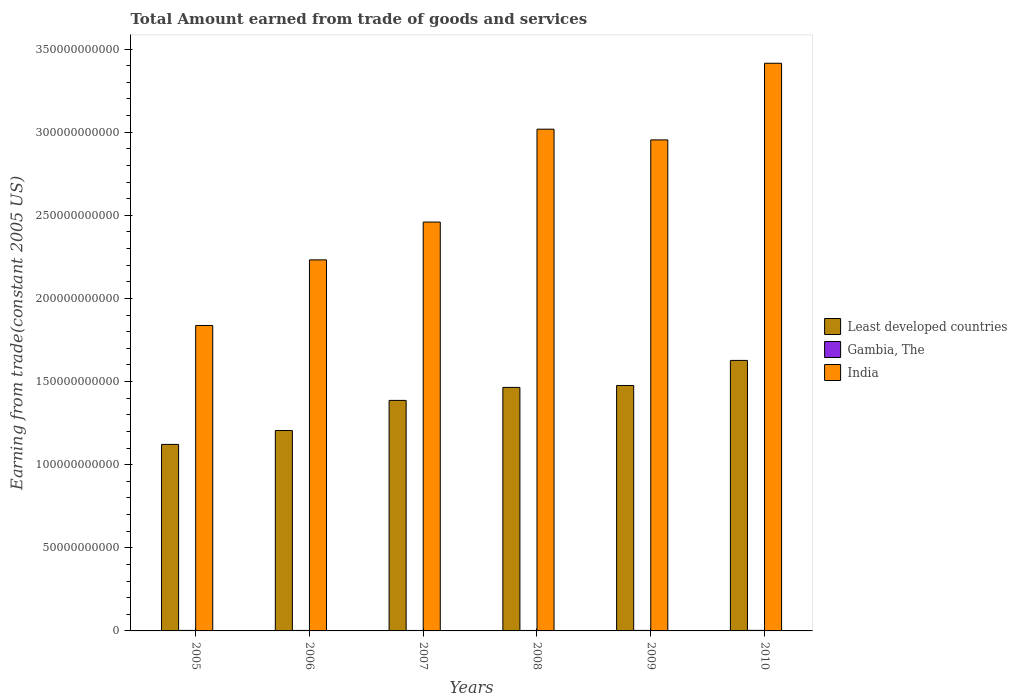How many different coloured bars are there?
Give a very brief answer. 3. How many groups of bars are there?
Provide a short and direct response. 6. Are the number of bars on each tick of the X-axis equal?
Provide a short and direct response. Yes. How many bars are there on the 4th tick from the left?
Your answer should be compact. 3. How many bars are there on the 5th tick from the right?
Your response must be concise. 3. In how many cases, is the number of bars for a given year not equal to the number of legend labels?
Offer a very short reply. 0. What is the total amount earned by trading goods and services in Gambia, The in 2006?
Ensure brevity in your answer.  2.98e+08. Across all years, what is the maximum total amount earned by trading goods and services in Least developed countries?
Your answer should be very brief. 1.63e+11. Across all years, what is the minimum total amount earned by trading goods and services in Gambia, The?
Provide a succinct answer. 2.75e+08. In which year was the total amount earned by trading goods and services in Gambia, The minimum?
Make the answer very short. 2007. What is the total total amount earned by trading goods and services in India in the graph?
Your answer should be very brief. 1.59e+12. What is the difference between the total amount earned by trading goods and services in Least developed countries in 2009 and that in 2010?
Offer a very short reply. -1.51e+1. What is the difference between the total amount earned by trading goods and services in Gambia, The in 2005 and the total amount earned by trading goods and services in Least developed countries in 2006?
Your response must be concise. -1.20e+11. What is the average total amount earned by trading goods and services in Gambia, The per year?
Keep it short and to the point. 3.00e+08. In the year 2005, what is the difference between the total amount earned by trading goods and services in Gambia, The and total amount earned by trading goods and services in India?
Make the answer very short. -1.83e+11. In how many years, is the total amount earned by trading goods and services in India greater than 130000000000 US$?
Provide a succinct answer. 6. What is the ratio of the total amount earned by trading goods and services in Least developed countries in 2006 to that in 2007?
Make the answer very short. 0.87. What is the difference between the highest and the second highest total amount earned by trading goods and services in Gambia, The?
Your answer should be very brief. 2.56e+07. What is the difference between the highest and the lowest total amount earned by trading goods and services in India?
Offer a very short reply. 1.58e+11. In how many years, is the total amount earned by trading goods and services in Least developed countries greater than the average total amount earned by trading goods and services in Least developed countries taken over all years?
Give a very brief answer. 4. Is the sum of the total amount earned by trading goods and services in Gambia, The in 2005 and 2006 greater than the maximum total amount earned by trading goods and services in India across all years?
Offer a terse response. No. What does the 3rd bar from the right in 2006 represents?
Your answer should be compact. Least developed countries. Is it the case that in every year, the sum of the total amount earned by trading goods and services in Least developed countries and total amount earned by trading goods and services in India is greater than the total amount earned by trading goods and services in Gambia, The?
Your answer should be compact. Yes. How many bars are there?
Your answer should be compact. 18. How many years are there in the graph?
Offer a very short reply. 6. What is the difference between two consecutive major ticks on the Y-axis?
Your answer should be very brief. 5.00e+1. Does the graph contain grids?
Ensure brevity in your answer.  No. How many legend labels are there?
Make the answer very short. 3. How are the legend labels stacked?
Make the answer very short. Vertical. What is the title of the graph?
Your answer should be compact. Total Amount earned from trade of goods and services. Does "Cambodia" appear as one of the legend labels in the graph?
Make the answer very short. No. What is the label or title of the X-axis?
Give a very brief answer. Years. What is the label or title of the Y-axis?
Your response must be concise. Earning from trade(constant 2005 US). What is the Earning from trade(constant 2005 US) in Least developed countries in 2005?
Ensure brevity in your answer.  1.12e+11. What is the Earning from trade(constant 2005 US) in Gambia, The in 2005?
Ensure brevity in your answer.  3.09e+08. What is the Earning from trade(constant 2005 US) of India in 2005?
Make the answer very short. 1.84e+11. What is the Earning from trade(constant 2005 US) in Least developed countries in 2006?
Offer a terse response. 1.21e+11. What is the Earning from trade(constant 2005 US) in Gambia, The in 2006?
Provide a short and direct response. 2.98e+08. What is the Earning from trade(constant 2005 US) in India in 2006?
Make the answer very short. 2.23e+11. What is the Earning from trade(constant 2005 US) in Least developed countries in 2007?
Keep it short and to the point. 1.39e+11. What is the Earning from trade(constant 2005 US) of Gambia, The in 2007?
Offer a very short reply. 2.75e+08. What is the Earning from trade(constant 2005 US) in India in 2007?
Your response must be concise. 2.46e+11. What is the Earning from trade(constant 2005 US) in Least developed countries in 2008?
Your answer should be very brief. 1.46e+11. What is the Earning from trade(constant 2005 US) of Gambia, The in 2008?
Your answer should be compact. 2.76e+08. What is the Earning from trade(constant 2005 US) of India in 2008?
Provide a short and direct response. 3.02e+11. What is the Earning from trade(constant 2005 US) of Least developed countries in 2009?
Provide a short and direct response. 1.48e+11. What is the Earning from trade(constant 2005 US) in Gambia, The in 2009?
Ensure brevity in your answer.  3.07e+08. What is the Earning from trade(constant 2005 US) in India in 2009?
Your answer should be very brief. 2.95e+11. What is the Earning from trade(constant 2005 US) of Least developed countries in 2010?
Ensure brevity in your answer.  1.63e+11. What is the Earning from trade(constant 2005 US) in Gambia, The in 2010?
Your response must be concise. 3.35e+08. What is the Earning from trade(constant 2005 US) of India in 2010?
Your answer should be compact. 3.41e+11. Across all years, what is the maximum Earning from trade(constant 2005 US) of Least developed countries?
Your answer should be very brief. 1.63e+11. Across all years, what is the maximum Earning from trade(constant 2005 US) in Gambia, The?
Your answer should be very brief. 3.35e+08. Across all years, what is the maximum Earning from trade(constant 2005 US) in India?
Ensure brevity in your answer.  3.41e+11. Across all years, what is the minimum Earning from trade(constant 2005 US) of Least developed countries?
Provide a short and direct response. 1.12e+11. Across all years, what is the minimum Earning from trade(constant 2005 US) in Gambia, The?
Make the answer very short. 2.75e+08. Across all years, what is the minimum Earning from trade(constant 2005 US) in India?
Your answer should be compact. 1.84e+11. What is the total Earning from trade(constant 2005 US) in Least developed countries in the graph?
Provide a short and direct response. 8.28e+11. What is the total Earning from trade(constant 2005 US) of Gambia, The in the graph?
Ensure brevity in your answer.  1.80e+09. What is the total Earning from trade(constant 2005 US) in India in the graph?
Offer a terse response. 1.59e+12. What is the difference between the Earning from trade(constant 2005 US) of Least developed countries in 2005 and that in 2006?
Offer a terse response. -8.35e+09. What is the difference between the Earning from trade(constant 2005 US) of Gambia, The in 2005 and that in 2006?
Your answer should be compact. 1.14e+07. What is the difference between the Earning from trade(constant 2005 US) of India in 2005 and that in 2006?
Give a very brief answer. -3.95e+1. What is the difference between the Earning from trade(constant 2005 US) of Least developed countries in 2005 and that in 2007?
Offer a very short reply. -2.65e+1. What is the difference between the Earning from trade(constant 2005 US) of Gambia, The in 2005 and that in 2007?
Provide a succinct answer. 3.42e+07. What is the difference between the Earning from trade(constant 2005 US) of India in 2005 and that in 2007?
Provide a succinct answer. -6.22e+1. What is the difference between the Earning from trade(constant 2005 US) in Least developed countries in 2005 and that in 2008?
Ensure brevity in your answer.  -3.43e+1. What is the difference between the Earning from trade(constant 2005 US) in Gambia, The in 2005 and that in 2008?
Offer a very short reply. 3.35e+07. What is the difference between the Earning from trade(constant 2005 US) in India in 2005 and that in 2008?
Keep it short and to the point. -1.18e+11. What is the difference between the Earning from trade(constant 2005 US) in Least developed countries in 2005 and that in 2009?
Keep it short and to the point. -3.54e+1. What is the difference between the Earning from trade(constant 2005 US) in Gambia, The in 2005 and that in 2009?
Keep it short and to the point. 2.33e+06. What is the difference between the Earning from trade(constant 2005 US) in India in 2005 and that in 2009?
Provide a succinct answer. -1.12e+11. What is the difference between the Earning from trade(constant 2005 US) in Least developed countries in 2005 and that in 2010?
Provide a succinct answer. -5.05e+1. What is the difference between the Earning from trade(constant 2005 US) in Gambia, The in 2005 and that in 2010?
Ensure brevity in your answer.  -2.56e+07. What is the difference between the Earning from trade(constant 2005 US) in India in 2005 and that in 2010?
Your answer should be very brief. -1.58e+11. What is the difference between the Earning from trade(constant 2005 US) in Least developed countries in 2006 and that in 2007?
Your response must be concise. -1.81e+1. What is the difference between the Earning from trade(constant 2005 US) in Gambia, The in 2006 and that in 2007?
Offer a terse response. 2.28e+07. What is the difference between the Earning from trade(constant 2005 US) of India in 2006 and that in 2007?
Your answer should be compact. -2.28e+1. What is the difference between the Earning from trade(constant 2005 US) of Least developed countries in 2006 and that in 2008?
Your response must be concise. -2.59e+1. What is the difference between the Earning from trade(constant 2005 US) in Gambia, The in 2006 and that in 2008?
Provide a succinct answer. 2.22e+07. What is the difference between the Earning from trade(constant 2005 US) in India in 2006 and that in 2008?
Provide a succinct answer. -7.86e+1. What is the difference between the Earning from trade(constant 2005 US) in Least developed countries in 2006 and that in 2009?
Offer a very short reply. -2.71e+1. What is the difference between the Earning from trade(constant 2005 US) of Gambia, The in 2006 and that in 2009?
Make the answer very short. -9.03e+06. What is the difference between the Earning from trade(constant 2005 US) of India in 2006 and that in 2009?
Offer a very short reply. -7.22e+1. What is the difference between the Earning from trade(constant 2005 US) of Least developed countries in 2006 and that in 2010?
Offer a very short reply. -4.22e+1. What is the difference between the Earning from trade(constant 2005 US) in Gambia, The in 2006 and that in 2010?
Provide a succinct answer. -3.70e+07. What is the difference between the Earning from trade(constant 2005 US) in India in 2006 and that in 2010?
Provide a short and direct response. -1.18e+11. What is the difference between the Earning from trade(constant 2005 US) in Least developed countries in 2007 and that in 2008?
Offer a terse response. -7.82e+09. What is the difference between the Earning from trade(constant 2005 US) in Gambia, The in 2007 and that in 2008?
Ensure brevity in your answer.  -6.49e+05. What is the difference between the Earning from trade(constant 2005 US) in India in 2007 and that in 2008?
Provide a succinct answer. -5.59e+1. What is the difference between the Earning from trade(constant 2005 US) in Least developed countries in 2007 and that in 2009?
Ensure brevity in your answer.  -8.96e+09. What is the difference between the Earning from trade(constant 2005 US) of Gambia, The in 2007 and that in 2009?
Ensure brevity in your answer.  -3.19e+07. What is the difference between the Earning from trade(constant 2005 US) of India in 2007 and that in 2009?
Provide a short and direct response. -4.94e+1. What is the difference between the Earning from trade(constant 2005 US) of Least developed countries in 2007 and that in 2010?
Give a very brief answer. -2.40e+1. What is the difference between the Earning from trade(constant 2005 US) in Gambia, The in 2007 and that in 2010?
Your answer should be compact. -5.98e+07. What is the difference between the Earning from trade(constant 2005 US) in India in 2007 and that in 2010?
Your response must be concise. -9.55e+1. What is the difference between the Earning from trade(constant 2005 US) in Least developed countries in 2008 and that in 2009?
Ensure brevity in your answer.  -1.15e+09. What is the difference between the Earning from trade(constant 2005 US) in Gambia, The in 2008 and that in 2009?
Offer a terse response. -3.12e+07. What is the difference between the Earning from trade(constant 2005 US) in India in 2008 and that in 2009?
Ensure brevity in your answer.  6.45e+09. What is the difference between the Earning from trade(constant 2005 US) in Least developed countries in 2008 and that in 2010?
Your answer should be compact. -1.62e+1. What is the difference between the Earning from trade(constant 2005 US) in Gambia, The in 2008 and that in 2010?
Make the answer very short. -5.92e+07. What is the difference between the Earning from trade(constant 2005 US) in India in 2008 and that in 2010?
Give a very brief answer. -3.97e+1. What is the difference between the Earning from trade(constant 2005 US) in Least developed countries in 2009 and that in 2010?
Your answer should be very brief. -1.51e+1. What is the difference between the Earning from trade(constant 2005 US) in Gambia, The in 2009 and that in 2010?
Give a very brief answer. -2.80e+07. What is the difference between the Earning from trade(constant 2005 US) in India in 2009 and that in 2010?
Keep it short and to the point. -4.61e+1. What is the difference between the Earning from trade(constant 2005 US) of Least developed countries in 2005 and the Earning from trade(constant 2005 US) of Gambia, The in 2006?
Give a very brief answer. 1.12e+11. What is the difference between the Earning from trade(constant 2005 US) in Least developed countries in 2005 and the Earning from trade(constant 2005 US) in India in 2006?
Provide a short and direct response. -1.11e+11. What is the difference between the Earning from trade(constant 2005 US) in Gambia, The in 2005 and the Earning from trade(constant 2005 US) in India in 2006?
Your response must be concise. -2.23e+11. What is the difference between the Earning from trade(constant 2005 US) of Least developed countries in 2005 and the Earning from trade(constant 2005 US) of Gambia, The in 2007?
Provide a short and direct response. 1.12e+11. What is the difference between the Earning from trade(constant 2005 US) in Least developed countries in 2005 and the Earning from trade(constant 2005 US) in India in 2007?
Keep it short and to the point. -1.34e+11. What is the difference between the Earning from trade(constant 2005 US) of Gambia, The in 2005 and the Earning from trade(constant 2005 US) of India in 2007?
Offer a terse response. -2.46e+11. What is the difference between the Earning from trade(constant 2005 US) in Least developed countries in 2005 and the Earning from trade(constant 2005 US) in Gambia, The in 2008?
Offer a very short reply. 1.12e+11. What is the difference between the Earning from trade(constant 2005 US) of Least developed countries in 2005 and the Earning from trade(constant 2005 US) of India in 2008?
Your answer should be very brief. -1.90e+11. What is the difference between the Earning from trade(constant 2005 US) in Gambia, The in 2005 and the Earning from trade(constant 2005 US) in India in 2008?
Give a very brief answer. -3.02e+11. What is the difference between the Earning from trade(constant 2005 US) of Least developed countries in 2005 and the Earning from trade(constant 2005 US) of Gambia, The in 2009?
Offer a terse response. 1.12e+11. What is the difference between the Earning from trade(constant 2005 US) of Least developed countries in 2005 and the Earning from trade(constant 2005 US) of India in 2009?
Provide a succinct answer. -1.83e+11. What is the difference between the Earning from trade(constant 2005 US) in Gambia, The in 2005 and the Earning from trade(constant 2005 US) in India in 2009?
Keep it short and to the point. -2.95e+11. What is the difference between the Earning from trade(constant 2005 US) in Least developed countries in 2005 and the Earning from trade(constant 2005 US) in Gambia, The in 2010?
Provide a succinct answer. 1.12e+11. What is the difference between the Earning from trade(constant 2005 US) in Least developed countries in 2005 and the Earning from trade(constant 2005 US) in India in 2010?
Your answer should be compact. -2.29e+11. What is the difference between the Earning from trade(constant 2005 US) of Gambia, The in 2005 and the Earning from trade(constant 2005 US) of India in 2010?
Offer a terse response. -3.41e+11. What is the difference between the Earning from trade(constant 2005 US) in Least developed countries in 2006 and the Earning from trade(constant 2005 US) in Gambia, The in 2007?
Keep it short and to the point. 1.20e+11. What is the difference between the Earning from trade(constant 2005 US) in Least developed countries in 2006 and the Earning from trade(constant 2005 US) in India in 2007?
Your response must be concise. -1.25e+11. What is the difference between the Earning from trade(constant 2005 US) of Gambia, The in 2006 and the Earning from trade(constant 2005 US) of India in 2007?
Provide a short and direct response. -2.46e+11. What is the difference between the Earning from trade(constant 2005 US) of Least developed countries in 2006 and the Earning from trade(constant 2005 US) of Gambia, The in 2008?
Your answer should be compact. 1.20e+11. What is the difference between the Earning from trade(constant 2005 US) in Least developed countries in 2006 and the Earning from trade(constant 2005 US) in India in 2008?
Your answer should be very brief. -1.81e+11. What is the difference between the Earning from trade(constant 2005 US) in Gambia, The in 2006 and the Earning from trade(constant 2005 US) in India in 2008?
Offer a very short reply. -3.02e+11. What is the difference between the Earning from trade(constant 2005 US) of Least developed countries in 2006 and the Earning from trade(constant 2005 US) of Gambia, The in 2009?
Your answer should be very brief. 1.20e+11. What is the difference between the Earning from trade(constant 2005 US) in Least developed countries in 2006 and the Earning from trade(constant 2005 US) in India in 2009?
Give a very brief answer. -1.75e+11. What is the difference between the Earning from trade(constant 2005 US) in Gambia, The in 2006 and the Earning from trade(constant 2005 US) in India in 2009?
Offer a very short reply. -2.95e+11. What is the difference between the Earning from trade(constant 2005 US) in Least developed countries in 2006 and the Earning from trade(constant 2005 US) in Gambia, The in 2010?
Make the answer very short. 1.20e+11. What is the difference between the Earning from trade(constant 2005 US) of Least developed countries in 2006 and the Earning from trade(constant 2005 US) of India in 2010?
Keep it short and to the point. -2.21e+11. What is the difference between the Earning from trade(constant 2005 US) in Gambia, The in 2006 and the Earning from trade(constant 2005 US) in India in 2010?
Ensure brevity in your answer.  -3.41e+11. What is the difference between the Earning from trade(constant 2005 US) of Least developed countries in 2007 and the Earning from trade(constant 2005 US) of Gambia, The in 2008?
Your answer should be very brief. 1.38e+11. What is the difference between the Earning from trade(constant 2005 US) in Least developed countries in 2007 and the Earning from trade(constant 2005 US) in India in 2008?
Your answer should be very brief. -1.63e+11. What is the difference between the Earning from trade(constant 2005 US) in Gambia, The in 2007 and the Earning from trade(constant 2005 US) in India in 2008?
Provide a succinct answer. -3.02e+11. What is the difference between the Earning from trade(constant 2005 US) of Least developed countries in 2007 and the Earning from trade(constant 2005 US) of Gambia, The in 2009?
Make the answer very short. 1.38e+11. What is the difference between the Earning from trade(constant 2005 US) of Least developed countries in 2007 and the Earning from trade(constant 2005 US) of India in 2009?
Provide a short and direct response. -1.57e+11. What is the difference between the Earning from trade(constant 2005 US) of Gambia, The in 2007 and the Earning from trade(constant 2005 US) of India in 2009?
Your answer should be compact. -2.95e+11. What is the difference between the Earning from trade(constant 2005 US) in Least developed countries in 2007 and the Earning from trade(constant 2005 US) in Gambia, The in 2010?
Provide a short and direct response. 1.38e+11. What is the difference between the Earning from trade(constant 2005 US) in Least developed countries in 2007 and the Earning from trade(constant 2005 US) in India in 2010?
Your answer should be compact. -2.03e+11. What is the difference between the Earning from trade(constant 2005 US) of Gambia, The in 2007 and the Earning from trade(constant 2005 US) of India in 2010?
Offer a very short reply. -3.41e+11. What is the difference between the Earning from trade(constant 2005 US) in Least developed countries in 2008 and the Earning from trade(constant 2005 US) in Gambia, The in 2009?
Provide a short and direct response. 1.46e+11. What is the difference between the Earning from trade(constant 2005 US) of Least developed countries in 2008 and the Earning from trade(constant 2005 US) of India in 2009?
Provide a succinct answer. -1.49e+11. What is the difference between the Earning from trade(constant 2005 US) of Gambia, The in 2008 and the Earning from trade(constant 2005 US) of India in 2009?
Offer a very short reply. -2.95e+11. What is the difference between the Earning from trade(constant 2005 US) of Least developed countries in 2008 and the Earning from trade(constant 2005 US) of Gambia, The in 2010?
Ensure brevity in your answer.  1.46e+11. What is the difference between the Earning from trade(constant 2005 US) of Least developed countries in 2008 and the Earning from trade(constant 2005 US) of India in 2010?
Give a very brief answer. -1.95e+11. What is the difference between the Earning from trade(constant 2005 US) of Gambia, The in 2008 and the Earning from trade(constant 2005 US) of India in 2010?
Your response must be concise. -3.41e+11. What is the difference between the Earning from trade(constant 2005 US) in Least developed countries in 2009 and the Earning from trade(constant 2005 US) in Gambia, The in 2010?
Provide a short and direct response. 1.47e+11. What is the difference between the Earning from trade(constant 2005 US) in Least developed countries in 2009 and the Earning from trade(constant 2005 US) in India in 2010?
Give a very brief answer. -1.94e+11. What is the difference between the Earning from trade(constant 2005 US) of Gambia, The in 2009 and the Earning from trade(constant 2005 US) of India in 2010?
Your answer should be very brief. -3.41e+11. What is the average Earning from trade(constant 2005 US) of Least developed countries per year?
Your answer should be very brief. 1.38e+11. What is the average Earning from trade(constant 2005 US) in Gambia, The per year?
Offer a very short reply. 3.00e+08. What is the average Earning from trade(constant 2005 US) in India per year?
Offer a terse response. 2.65e+11. In the year 2005, what is the difference between the Earning from trade(constant 2005 US) in Least developed countries and Earning from trade(constant 2005 US) in Gambia, The?
Provide a succinct answer. 1.12e+11. In the year 2005, what is the difference between the Earning from trade(constant 2005 US) of Least developed countries and Earning from trade(constant 2005 US) of India?
Make the answer very short. -7.15e+1. In the year 2005, what is the difference between the Earning from trade(constant 2005 US) of Gambia, The and Earning from trade(constant 2005 US) of India?
Offer a terse response. -1.83e+11. In the year 2006, what is the difference between the Earning from trade(constant 2005 US) of Least developed countries and Earning from trade(constant 2005 US) of Gambia, The?
Offer a terse response. 1.20e+11. In the year 2006, what is the difference between the Earning from trade(constant 2005 US) of Least developed countries and Earning from trade(constant 2005 US) of India?
Keep it short and to the point. -1.03e+11. In the year 2006, what is the difference between the Earning from trade(constant 2005 US) of Gambia, The and Earning from trade(constant 2005 US) of India?
Offer a terse response. -2.23e+11. In the year 2007, what is the difference between the Earning from trade(constant 2005 US) of Least developed countries and Earning from trade(constant 2005 US) of Gambia, The?
Offer a very short reply. 1.38e+11. In the year 2007, what is the difference between the Earning from trade(constant 2005 US) in Least developed countries and Earning from trade(constant 2005 US) in India?
Make the answer very short. -1.07e+11. In the year 2007, what is the difference between the Earning from trade(constant 2005 US) of Gambia, The and Earning from trade(constant 2005 US) of India?
Make the answer very short. -2.46e+11. In the year 2008, what is the difference between the Earning from trade(constant 2005 US) in Least developed countries and Earning from trade(constant 2005 US) in Gambia, The?
Give a very brief answer. 1.46e+11. In the year 2008, what is the difference between the Earning from trade(constant 2005 US) of Least developed countries and Earning from trade(constant 2005 US) of India?
Provide a short and direct response. -1.55e+11. In the year 2008, what is the difference between the Earning from trade(constant 2005 US) in Gambia, The and Earning from trade(constant 2005 US) in India?
Make the answer very short. -3.02e+11. In the year 2009, what is the difference between the Earning from trade(constant 2005 US) in Least developed countries and Earning from trade(constant 2005 US) in Gambia, The?
Your response must be concise. 1.47e+11. In the year 2009, what is the difference between the Earning from trade(constant 2005 US) in Least developed countries and Earning from trade(constant 2005 US) in India?
Make the answer very short. -1.48e+11. In the year 2009, what is the difference between the Earning from trade(constant 2005 US) in Gambia, The and Earning from trade(constant 2005 US) in India?
Offer a very short reply. -2.95e+11. In the year 2010, what is the difference between the Earning from trade(constant 2005 US) in Least developed countries and Earning from trade(constant 2005 US) in Gambia, The?
Provide a succinct answer. 1.62e+11. In the year 2010, what is the difference between the Earning from trade(constant 2005 US) of Least developed countries and Earning from trade(constant 2005 US) of India?
Keep it short and to the point. -1.79e+11. In the year 2010, what is the difference between the Earning from trade(constant 2005 US) of Gambia, The and Earning from trade(constant 2005 US) of India?
Provide a short and direct response. -3.41e+11. What is the ratio of the Earning from trade(constant 2005 US) in Least developed countries in 2005 to that in 2006?
Offer a very short reply. 0.93. What is the ratio of the Earning from trade(constant 2005 US) of Gambia, The in 2005 to that in 2006?
Give a very brief answer. 1.04. What is the ratio of the Earning from trade(constant 2005 US) of India in 2005 to that in 2006?
Your answer should be very brief. 0.82. What is the ratio of the Earning from trade(constant 2005 US) of Least developed countries in 2005 to that in 2007?
Your response must be concise. 0.81. What is the ratio of the Earning from trade(constant 2005 US) of Gambia, The in 2005 to that in 2007?
Your response must be concise. 1.12. What is the ratio of the Earning from trade(constant 2005 US) in India in 2005 to that in 2007?
Provide a succinct answer. 0.75. What is the ratio of the Earning from trade(constant 2005 US) in Least developed countries in 2005 to that in 2008?
Your answer should be very brief. 0.77. What is the ratio of the Earning from trade(constant 2005 US) in Gambia, The in 2005 to that in 2008?
Offer a very short reply. 1.12. What is the ratio of the Earning from trade(constant 2005 US) in India in 2005 to that in 2008?
Ensure brevity in your answer.  0.61. What is the ratio of the Earning from trade(constant 2005 US) in Least developed countries in 2005 to that in 2009?
Provide a succinct answer. 0.76. What is the ratio of the Earning from trade(constant 2005 US) of Gambia, The in 2005 to that in 2009?
Your answer should be very brief. 1.01. What is the ratio of the Earning from trade(constant 2005 US) in India in 2005 to that in 2009?
Your answer should be compact. 0.62. What is the ratio of the Earning from trade(constant 2005 US) of Least developed countries in 2005 to that in 2010?
Make the answer very short. 0.69. What is the ratio of the Earning from trade(constant 2005 US) in Gambia, The in 2005 to that in 2010?
Make the answer very short. 0.92. What is the ratio of the Earning from trade(constant 2005 US) of India in 2005 to that in 2010?
Your answer should be very brief. 0.54. What is the ratio of the Earning from trade(constant 2005 US) of Least developed countries in 2006 to that in 2007?
Ensure brevity in your answer.  0.87. What is the ratio of the Earning from trade(constant 2005 US) in Gambia, The in 2006 to that in 2007?
Your answer should be compact. 1.08. What is the ratio of the Earning from trade(constant 2005 US) of India in 2006 to that in 2007?
Give a very brief answer. 0.91. What is the ratio of the Earning from trade(constant 2005 US) of Least developed countries in 2006 to that in 2008?
Offer a very short reply. 0.82. What is the ratio of the Earning from trade(constant 2005 US) of Gambia, The in 2006 to that in 2008?
Your answer should be compact. 1.08. What is the ratio of the Earning from trade(constant 2005 US) of India in 2006 to that in 2008?
Offer a terse response. 0.74. What is the ratio of the Earning from trade(constant 2005 US) in Least developed countries in 2006 to that in 2009?
Make the answer very short. 0.82. What is the ratio of the Earning from trade(constant 2005 US) of Gambia, The in 2006 to that in 2009?
Offer a very short reply. 0.97. What is the ratio of the Earning from trade(constant 2005 US) in India in 2006 to that in 2009?
Your answer should be very brief. 0.76. What is the ratio of the Earning from trade(constant 2005 US) of Least developed countries in 2006 to that in 2010?
Give a very brief answer. 0.74. What is the ratio of the Earning from trade(constant 2005 US) of Gambia, The in 2006 to that in 2010?
Your response must be concise. 0.89. What is the ratio of the Earning from trade(constant 2005 US) of India in 2006 to that in 2010?
Your answer should be compact. 0.65. What is the ratio of the Earning from trade(constant 2005 US) in Least developed countries in 2007 to that in 2008?
Offer a very short reply. 0.95. What is the ratio of the Earning from trade(constant 2005 US) of Gambia, The in 2007 to that in 2008?
Give a very brief answer. 1. What is the ratio of the Earning from trade(constant 2005 US) in India in 2007 to that in 2008?
Offer a very short reply. 0.81. What is the ratio of the Earning from trade(constant 2005 US) of Least developed countries in 2007 to that in 2009?
Your answer should be compact. 0.94. What is the ratio of the Earning from trade(constant 2005 US) in Gambia, The in 2007 to that in 2009?
Provide a short and direct response. 0.9. What is the ratio of the Earning from trade(constant 2005 US) of India in 2007 to that in 2009?
Provide a succinct answer. 0.83. What is the ratio of the Earning from trade(constant 2005 US) in Least developed countries in 2007 to that in 2010?
Give a very brief answer. 0.85. What is the ratio of the Earning from trade(constant 2005 US) in Gambia, The in 2007 to that in 2010?
Give a very brief answer. 0.82. What is the ratio of the Earning from trade(constant 2005 US) of India in 2007 to that in 2010?
Make the answer very short. 0.72. What is the ratio of the Earning from trade(constant 2005 US) in Least developed countries in 2008 to that in 2009?
Make the answer very short. 0.99. What is the ratio of the Earning from trade(constant 2005 US) in Gambia, The in 2008 to that in 2009?
Your response must be concise. 0.9. What is the ratio of the Earning from trade(constant 2005 US) of India in 2008 to that in 2009?
Provide a succinct answer. 1.02. What is the ratio of the Earning from trade(constant 2005 US) of Least developed countries in 2008 to that in 2010?
Offer a terse response. 0.9. What is the ratio of the Earning from trade(constant 2005 US) of Gambia, The in 2008 to that in 2010?
Offer a terse response. 0.82. What is the ratio of the Earning from trade(constant 2005 US) in India in 2008 to that in 2010?
Make the answer very short. 0.88. What is the ratio of the Earning from trade(constant 2005 US) in Least developed countries in 2009 to that in 2010?
Your answer should be compact. 0.91. What is the ratio of the Earning from trade(constant 2005 US) in Gambia, The in 2009 to that in 2010?
Give a very brief answer. 0.92. What is the ratio of the Earning from trade(constant 2005 US) of India in 2009 to that in 2010?
Your answer should be very brief. 0.86. What is the difference between the highest and the second highest Earning from trade(constant 2005 US) of Least developed countries?
Your answer should be very brief. 1.51e+1. What is the difference between the highest and the second highest Earning from trade(constant 2005 US) of Gambia, The?
Keep it short and to the point. 2.56e+07. What is the difference between the highest and the second highest Earning from trade(constant 2005 US) in India?
Keep it short and to the point. 3.97e+1. What is the difference between the highest and the lowest Earning from trade(constant 2005 US) of Least developed countries?
Your answer should be compact. 5.05e+1. What is the difference between the highest and the lowest Earning from trade(constant 2005 US) in Gambia, The?
Provide a succinct answer. 5.98e+07. What is the difference between the highest and the lowest Earning from trade(constant 2005 US) of India?
Your answer should be very brief. 1.58e+11. 